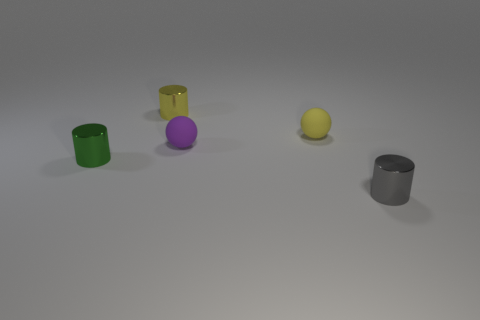There is a metal cylinder that is left of the metallic thing that is behind the tiny matte sphere left of the yellow sphere; what color is it? The cylindrical object located to the left of the metallic item that is situated behind the small matte sphere, itself located to the left of the yellow sphere, is green. 